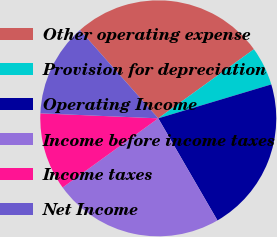<chart> <loc_0><loc_0><loc_500><loc_500><pie_chart><fcel>Other operating expense<fcel>Provision for depreciation<fcel>Operating Income<fcel>Income before income taxes<fcel>Income taxes<fcel>Net Income<nl><fcel>26.6%<fcel>5.32%<fcel>21.28%<fcel>23.4%<fcel>10.64%<fcel>12.77%<nl></chart> 